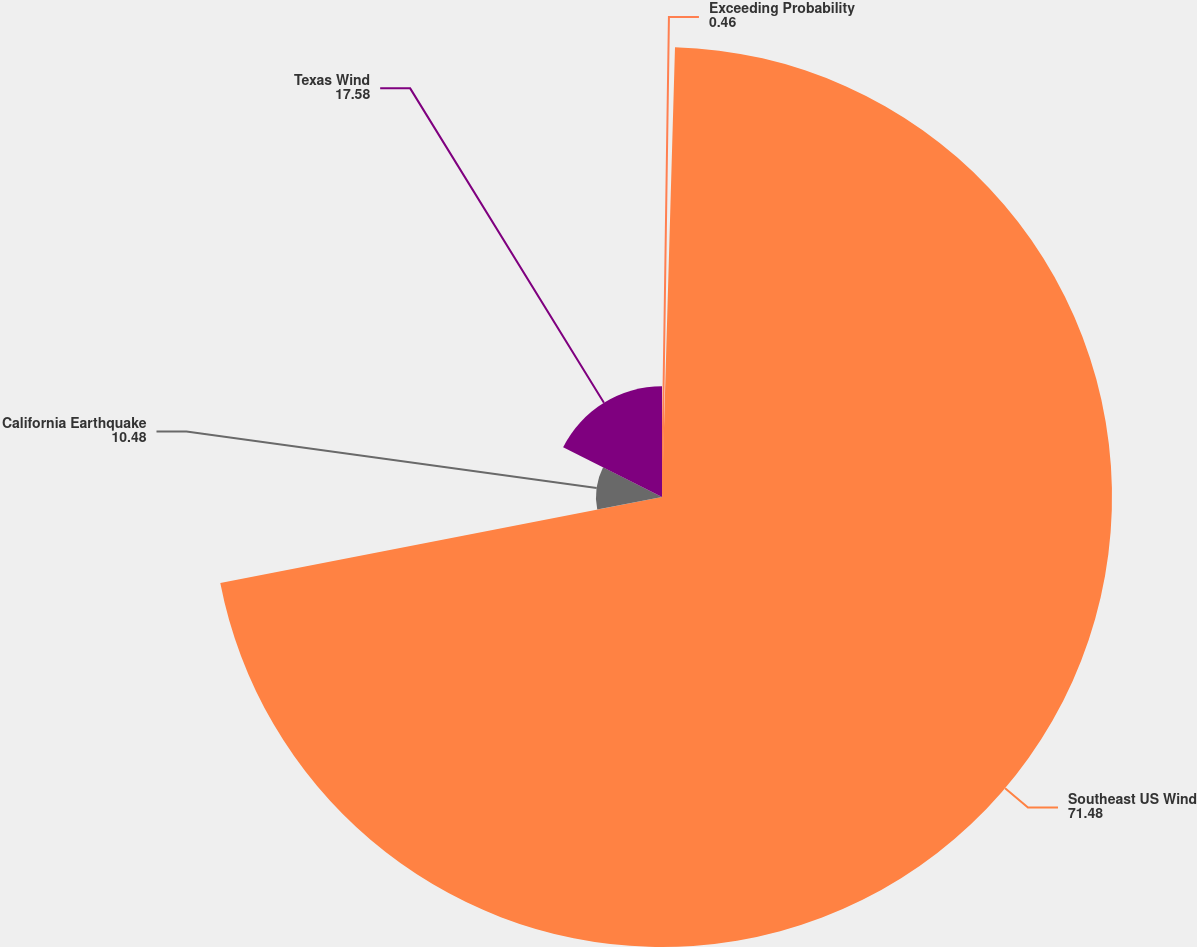<chart> <loc_0><loc_0><loc_500><loc_500><pie_chart><fcel>Exceeding Probability<fcel>Southeast US Wind<fcel>California Earthquake<fcel>Texas Wind<nl><fcel>0.46%<fcel>71.48%<fcel>10.48%<fcel>17.58%<nl></chart> 